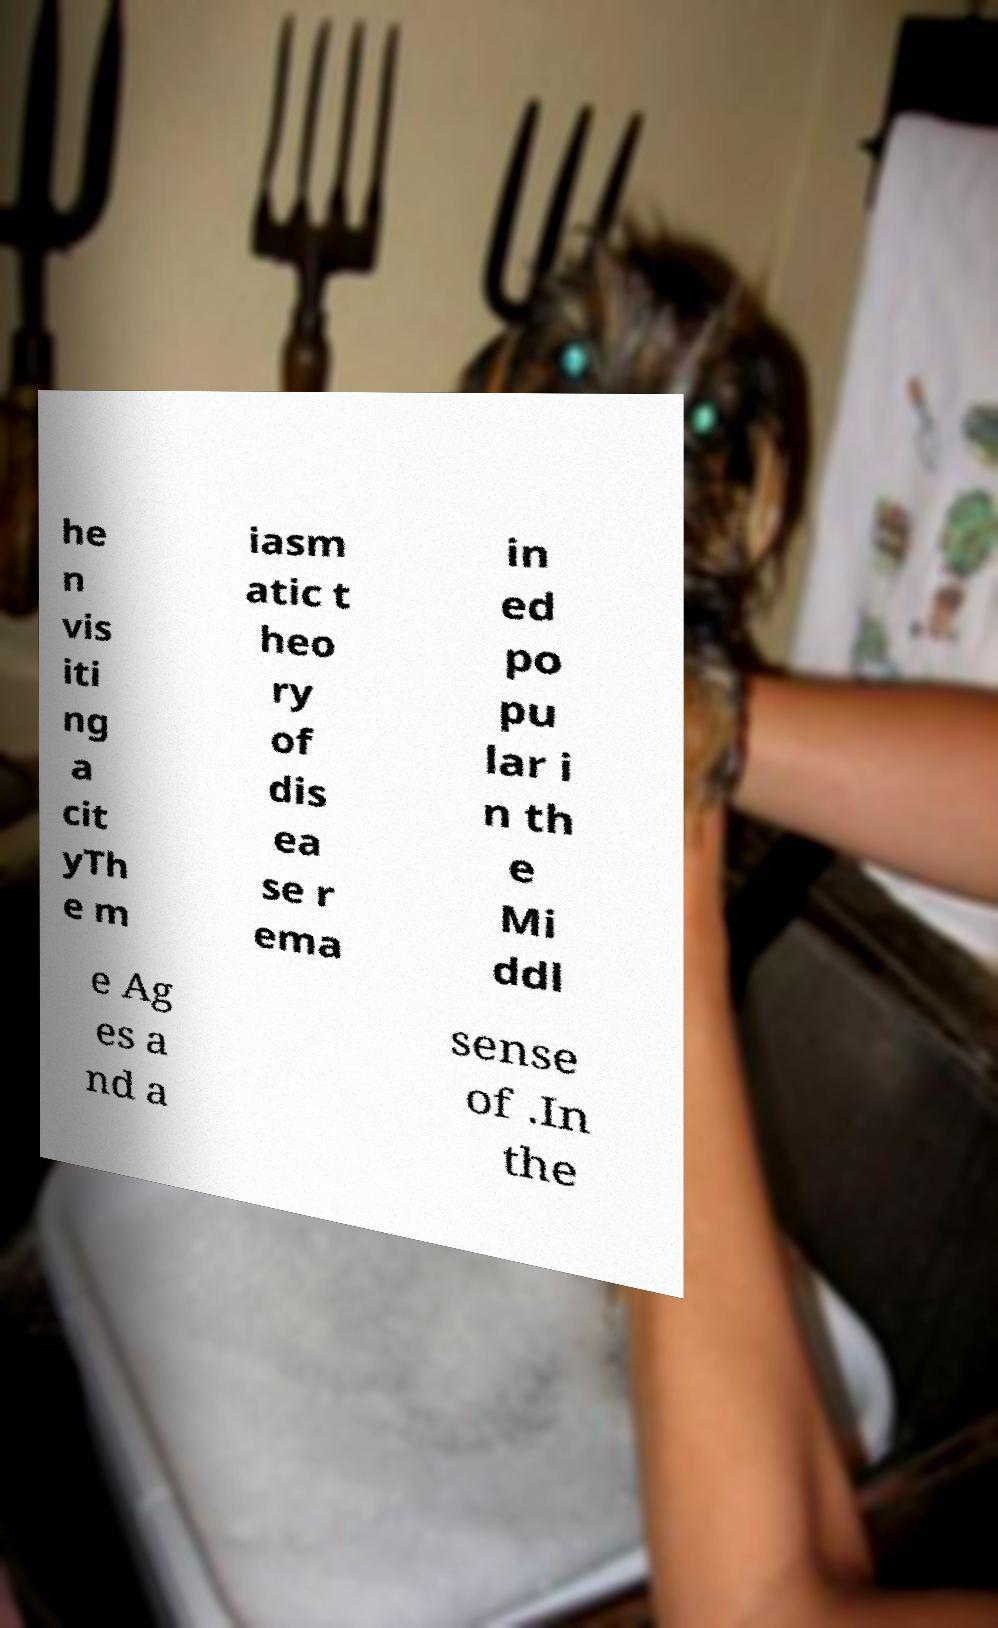Could you extract and type out the text from this image? he n vis iti ng a cit yTh e m iasm atic t heo ry of dis ea se r ema in ed po pu lar i n th e Mi ddl e Ag es a nd a sense of .In the 